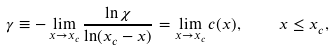<formula> <loc_0><loc_0><loc_500><loc_500>\gamma \equiv - \lim _ { x \rightarrow x _ { c } } \frac { \ln \chi } { \ln ( x _ { c } - x ) } = \lim _ { x \rightarrow x _ { c } } c ( x ) , \quad x \leq x _ { c } ,</formula> 